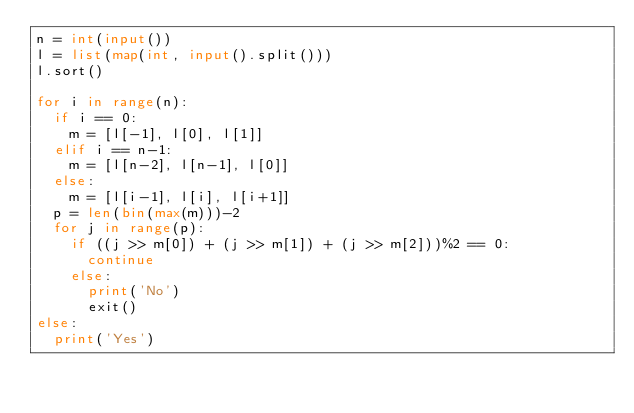<code> <loc_0><loc_0><loc_500><loc_500><_Python_>n = int(input())
l = list(map(int, input().split()))
l.sort()

for i in range(n):
  if i == 0:
    m = [l[-1], l[0], l[1]]
  elif i == n-1:
    m = [l[n-2], l[n-1], l[0]]
  else:
    m = [l[i-1], l[i], l[i+1]]
  p = len(bin(max(m)))-2
  for j in range(p):
    if ((j >> m[0]) + (j >> m[1]) + (j >> m[2]))%2 == 0:
      continue
    else:
      print('No')
      exit()
else:
  print('Yes')</code> 